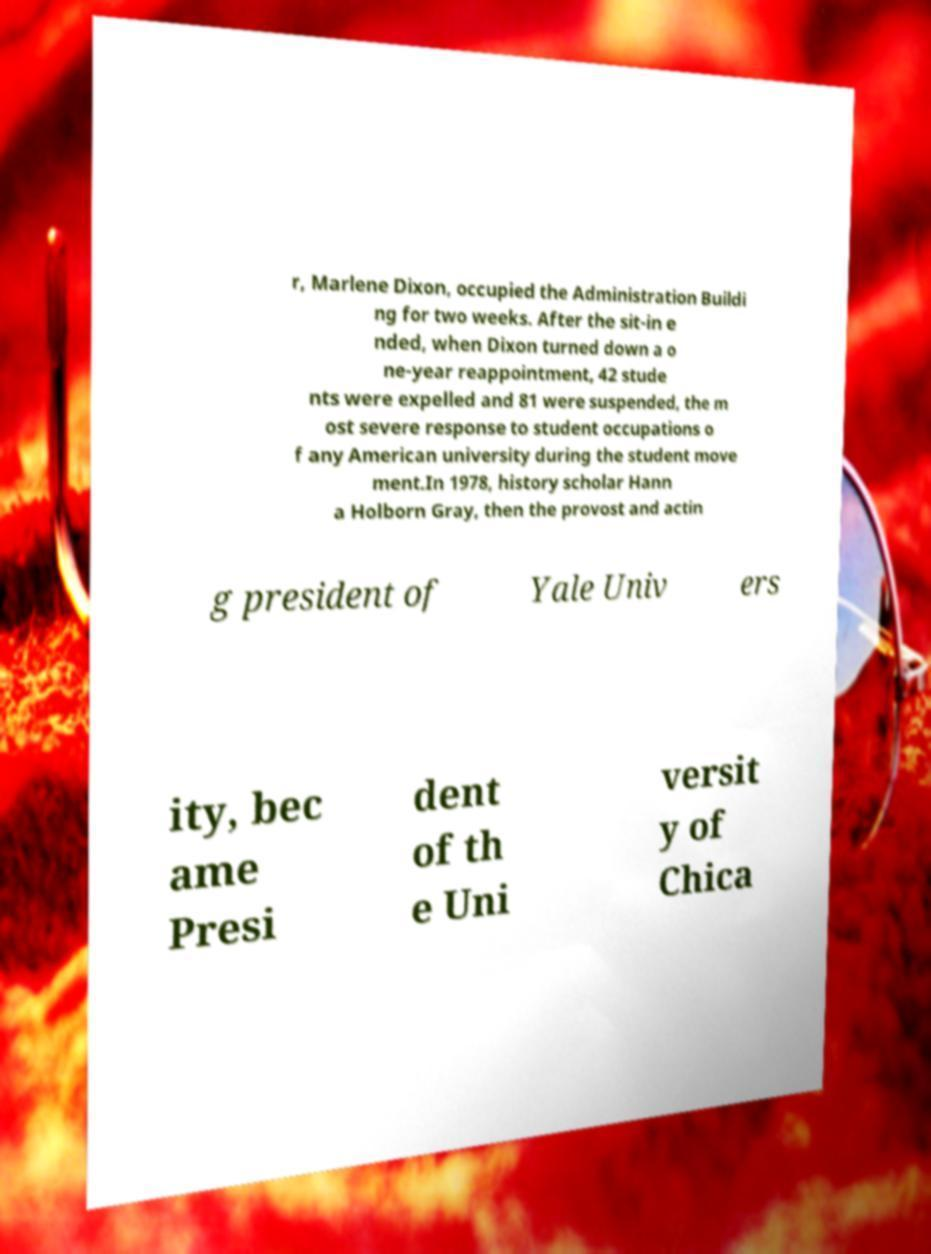Please identify and transcribe the text found in this image. r, Marlene Dixon, occupied the Administration Buildi ng for two weeks. After the sit-in e nded, when Dixon turned down a o ne-year reappointment, 42 stude nts were expelled and 81 were suspended, the m ost severe response to student occupations o f any American university during the student move ment.In 1978, history scholar Hann a Holborn Gray, then the provost and actin g president of Yale Univ ers ity, bec ame Presi dent of th e Uni versit y of Chica 